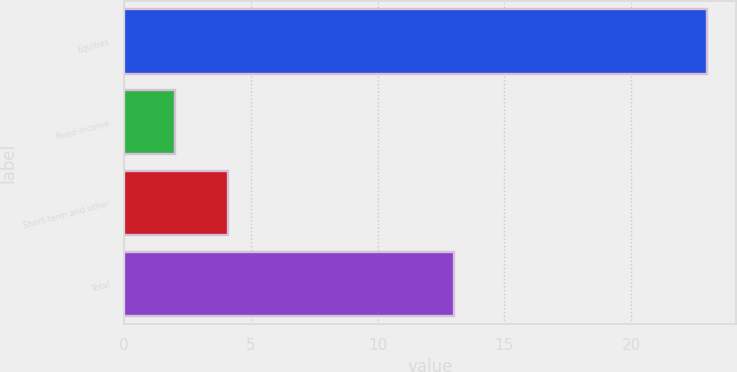Convert chart. <chart><loc_0><loc_0><loc_500><loc_500><bar_chart><fcel>Equities<fcel>Fixed-income<fcel>Short-term and other<fcel>Total<nl><fcel>23<fcel>2<fcel>4.1<fcel>13<nl></chart> 